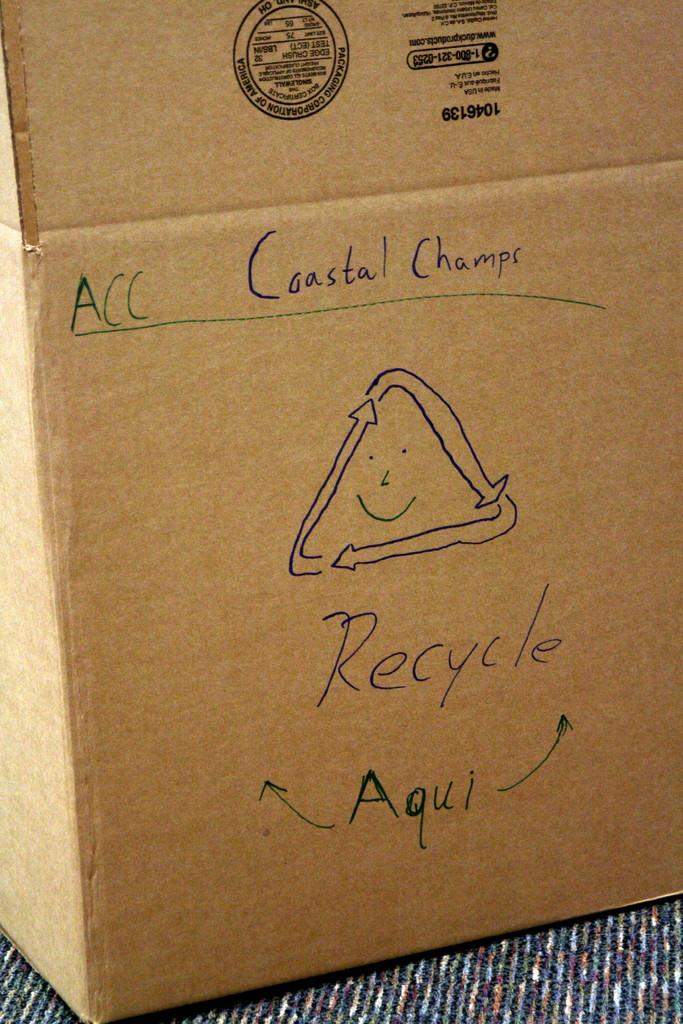<image>
Relay a brief, clear account of the picture shown. A cardboard box that has a recyling symbol and the word recycle written with black ink. 